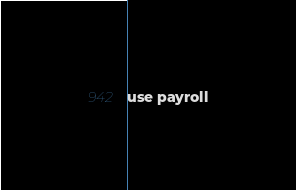<code> <loc_0><loc_0><loc_500><loc_500><_SQL_>use payroll

</code> 